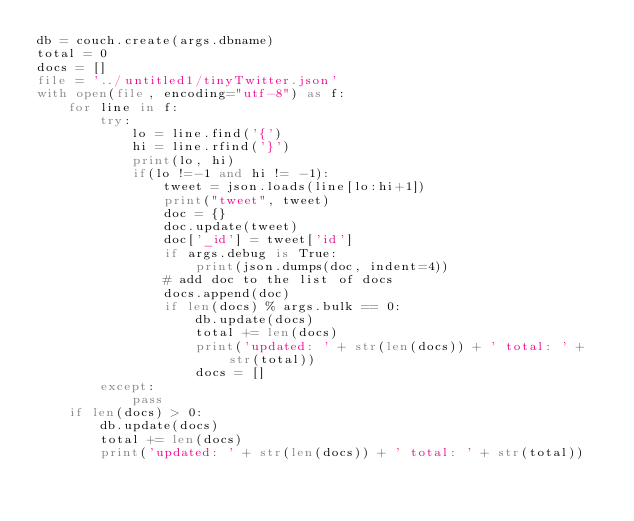Convert code to text. <code><loc_0><loc_0><loc_500><loc_500><_Python_>db = couch.create(args.dbname)
total = 0
docs = []
file = '../untitled1/tinyTwitter.json'
with open(file, encoding="utf-8") as f:
    for line in f:
        try:
            lo = line.find('{')
            hi = line.rfind('}')
            print(lo, hi)
            if(lo !=-1 and hi != -1):
                tweet = json.loads(line[lo:hi+1])
                print("tweet", tweet)
                doc = {}
                doc.update(tweet)
                doc['_id'] = tweet['id']
                if args.debug is True:
                    print(json.dumps(doc, indent=4))
                # add doc to the list of docs
                docs.append(doc)
                if len(docs) % args.bulk == 0:
                    db.update(docs)
                    total += len(docs)
                    print('updated: ' + str(len(docs)) + ' total: ' + str(total))
                    docs = []
        except:
            pass
    if len(docs) > 0:
        db.update(docs)
        total += len(docs)
        print('updated: ' + str(len(docs)) + ' total: ' + str(total))</code> 